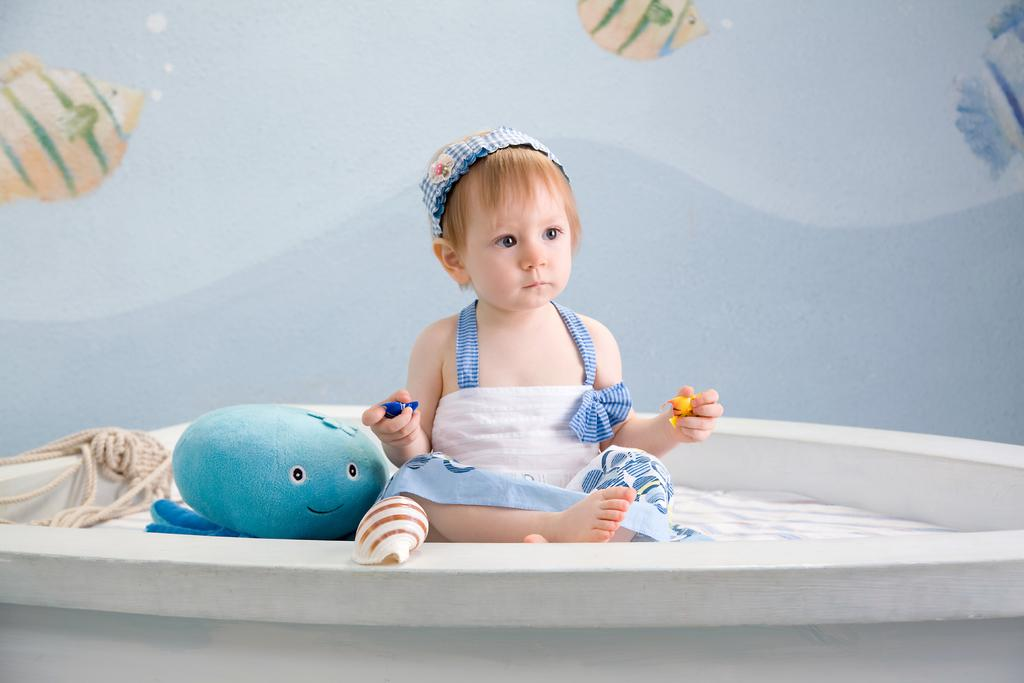What is the main subject of the image? The main subject of the image is a kid sitting. What is the kid holding in the image? The kid is holding objects, including a shell, a toy, and a rope. What can be seen in the background of the image? There is a wall poster in the background of the image. Where are the tomatoes stored in the image? There are no tomatoes present in the image. What route does the kid take to reach the drawer in the image? There is no drawer or route mentioned in the image. 